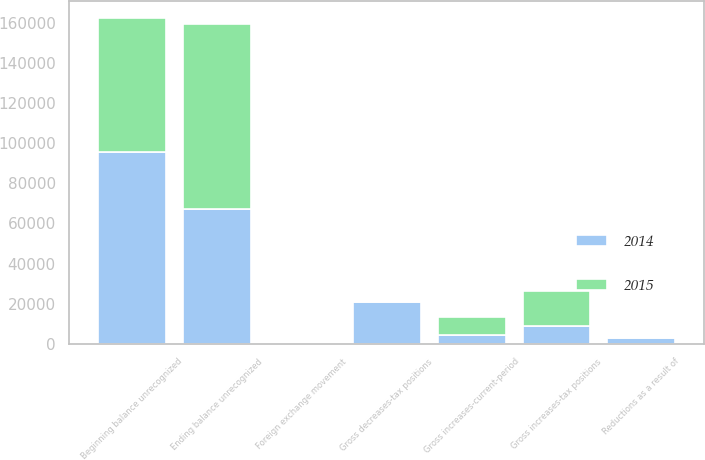<chart> <loc_0><loc_0><loc_500><loc_500><stacked_bar_chart><ecel><fcel>Beginning balance unrecognized<fcel>Gross increases-tax positions<fcel>Gross decreases-tax positions<fcel>Gross increases-current-period<fcel>Reductions as a result of<fcel>Foreign exchange movement<fcel>Ending balance unrecognized<nl><fcel>2015<fcel>66984<fcel>17545<fcel>92<fcel>8792<fcel>688<fcel>3<fcel>92538<nl><fcel>2014<fcel>95664<fcel>8864<fcel>20823<fcel>4431<fcel>2857<fcel>548<fcel>66984<nl></chart> 